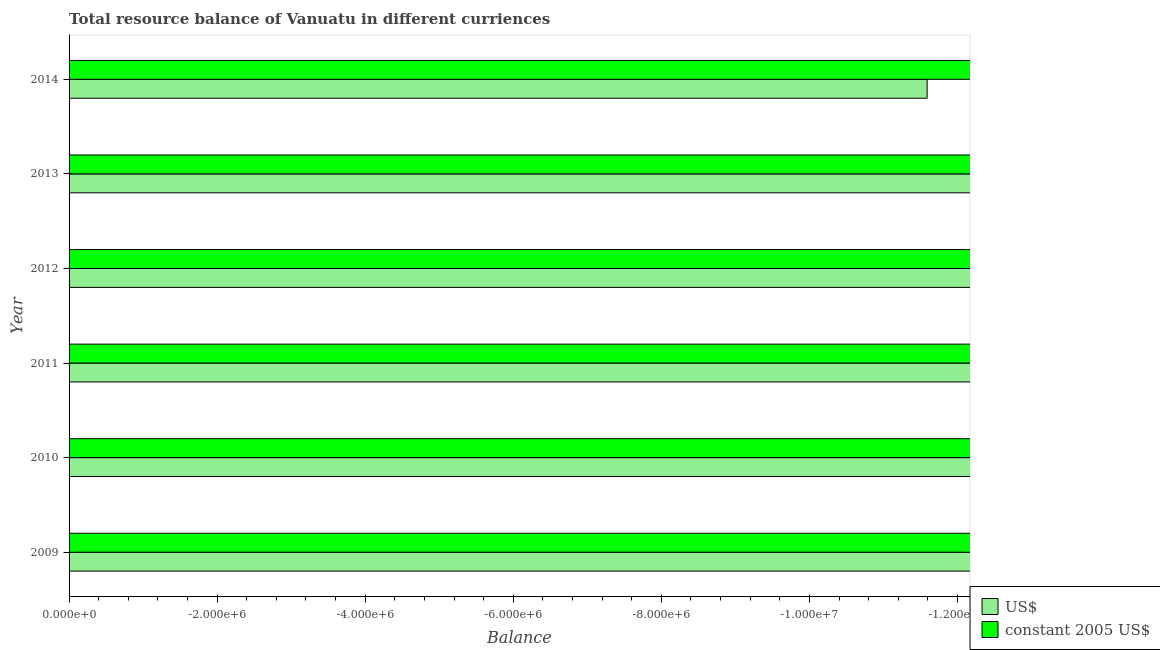Are the number of bars per tick equal to the number of legend labels?
Keep it short and to the point. No. What is the resource balance in us$ in 2010?
Give a very brief answer. 0. Across all years, what is the minimum resource balance in constant us$?
Keep it short and to the point. 0. What is the total resource balance in us$ in the graph?
Keep it short and to the point. 0. What is the average resource balance in constant us$ per year?
Offer a very short reply. 0. Are all the bars in the graph horizontal?
Provide a succinct answer. Yes. Does the graph contain any zero values?
Keep it short and to the point. Yes. What is the title of the graph?
Your answer should be compact. Total resource balance of Vanuatu in different curriences. Does "Methane emissions" appear as one of the legend labels in the graph?
Keep it short and to the point. No. What is the label or title of the X-axis?
Provide a short and direct response. Balance. What is the label or title of the Y-axis?
Offer a terse response. Year. What is the Balance of constant 2005 US$ in 2009?
Offer a terse response. 0. What is the Balance of US$ in 2010?
Ensure brevity in your answer.  0. What is the Balance of constant 2005 US$ in 2010?
Offer a terse response. 0. What is the Balance in constant 2005 US$ in 2011?
Keep it short and to the point. 0. What is the Balance of US$ in 2012?
Offer a terse response. 0. What is the Balance of constant 2005 US$ in 2012?
Your response must be concise. 0. What is the Balance of US$ in 2013?
Offer a very short reply. 0. What is the Balance of constant 2005 US$ in 2013?
Provide a succinct answer. 0. What is the Balance of constant 2005 US$ in 2014?
Provide a short and direct response. 0. What is the total Balance of US$ in the graph?
Provide a short and direct response. 0. What is the total Balance of constant 2005 US$ in the graph?
Provide a short and direct response. 0. What is the average Balance of US$ per year?
Ensure brevity in your answer.  0. What is the average Balance of constant 2005 US$ per year?
Provide a short and direct response. 0. 